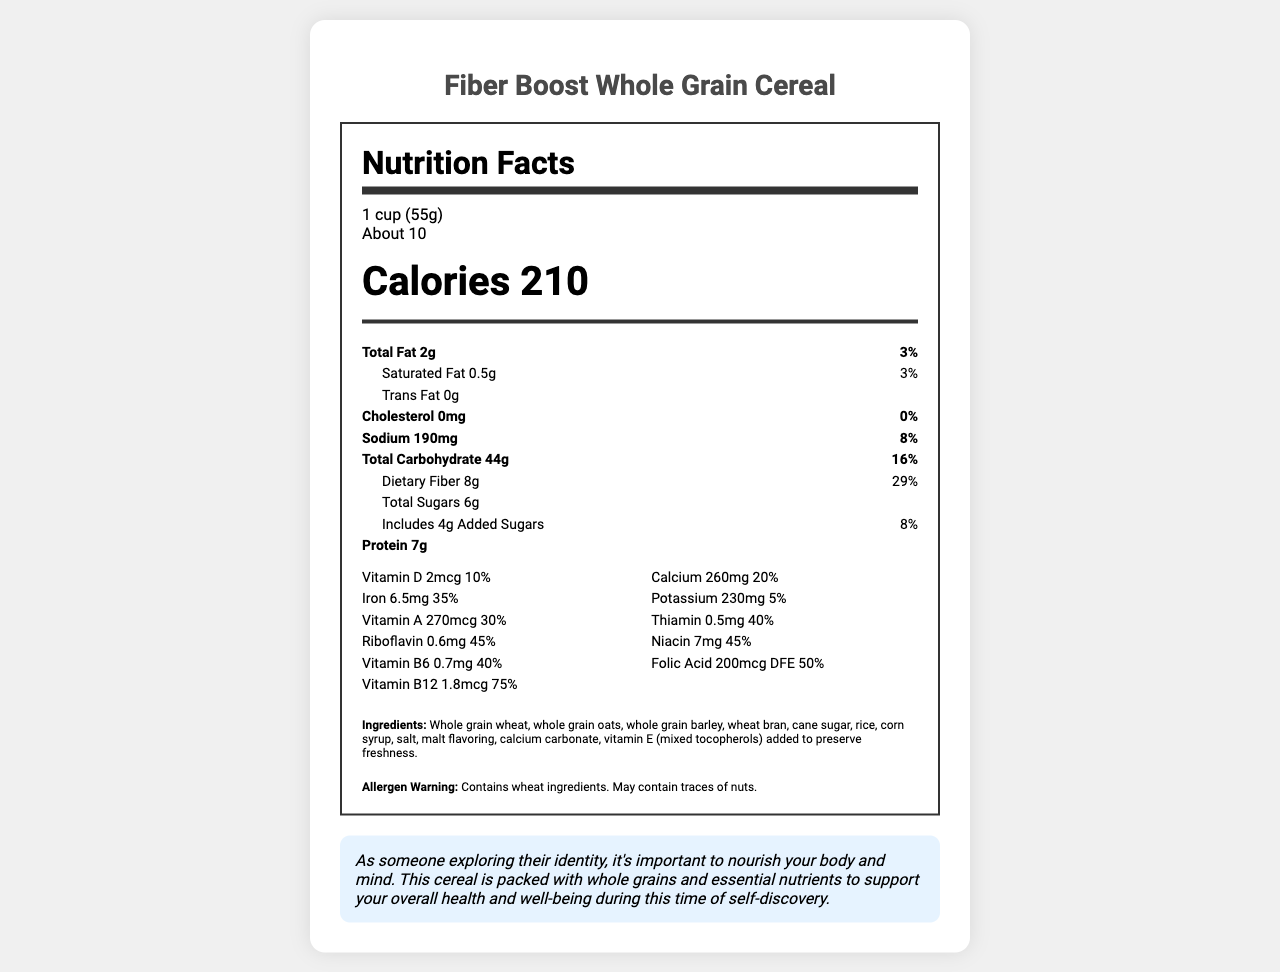what is the serving size for Fiber Boost Whole Grain Cereal? The serving size is clearly mentioned in the document as "1 cup (55g)".
Answer: 1 cup (55g) how many servings are in the container? The document states "Servings Per Container: About 10".
Answer: About 10 how many calories are in one serving of the cereal? The document lists "Calories 210" per serving.
Answer: 210 what is the daily value percentage of dietary fiber per serving? The document indicates that the daily value percentage for dietary fiber is "29%".
Answer: 29% name three vitamins found in Fiber Boost Whole Grain Cereal. The vitamins listed in the document include Vitamin D, Calcium, Iron, among others.
Answer: Vitamin D, Calcium, Iron which of the following nutrients has the highest daily value percentage in the cereal? A. Iron B. Riboflavin C. Vitamin B12 D. Folic Acid The daily value percentage for Vitamin B12 is the highest at 75%, compared to Iron (35%), Riboflavin (45%), and Folic Acid (50%).
Answer: C. Vitamin B12 what is the amount of added sugars in the cereal? The document lists "Includes 4g Added Sugars".
Answer: 4g does the cereal contain any cholesterol? The document states "Cholesterol 0mg", indicating no cholesterol.
Answer: No summarize the main nutritional qualities of Fiber Boost Whole Grain Cereal. The explanation includes key nutritional highlights: moderate calories, high fiber, notable protein, and a range of essential vitamins and minerals.
Answer: Fiber Boost Whole Grain Cereal provides a nutritious option with 210 calories per serving, high fiber (29% DV), moderate protein (7g), and significant amounts of essential vitamins and minerals, such as Iron (35% DV) and Vitamin B12 (75% DV). It contains whole grains and no cholesterol. what is the allergen warning for this cereal? The document clearly states the allergen warning as "Contains wheat ingredients. May contain traces of nuts."
Answer: Contains wheat ingredients. May contain traces of nuts. true or false: the cereal contains more protein than dietary fiber. The document shows the cereal contains 8g of dietary fiber and 7g of protein, so it has more fiber than protein.
Answer: False how much sodium is in one serving of the cereal? The amount of sodium is listed as "190mg".
Answer: 190mg is there any information on the daily value percentage of vitamin C in the cereal? The document does not mention Vitamin C, so the daily value percentage cannot be determined.
Answer: Not enough information what are the first three ingredients listed for the cereal? The first three ingredients listed are "Whole grain wheat, whole grain oats, whole grain barley".
Answer: Whole grain wheat, whole grain oats, whole grain barley 